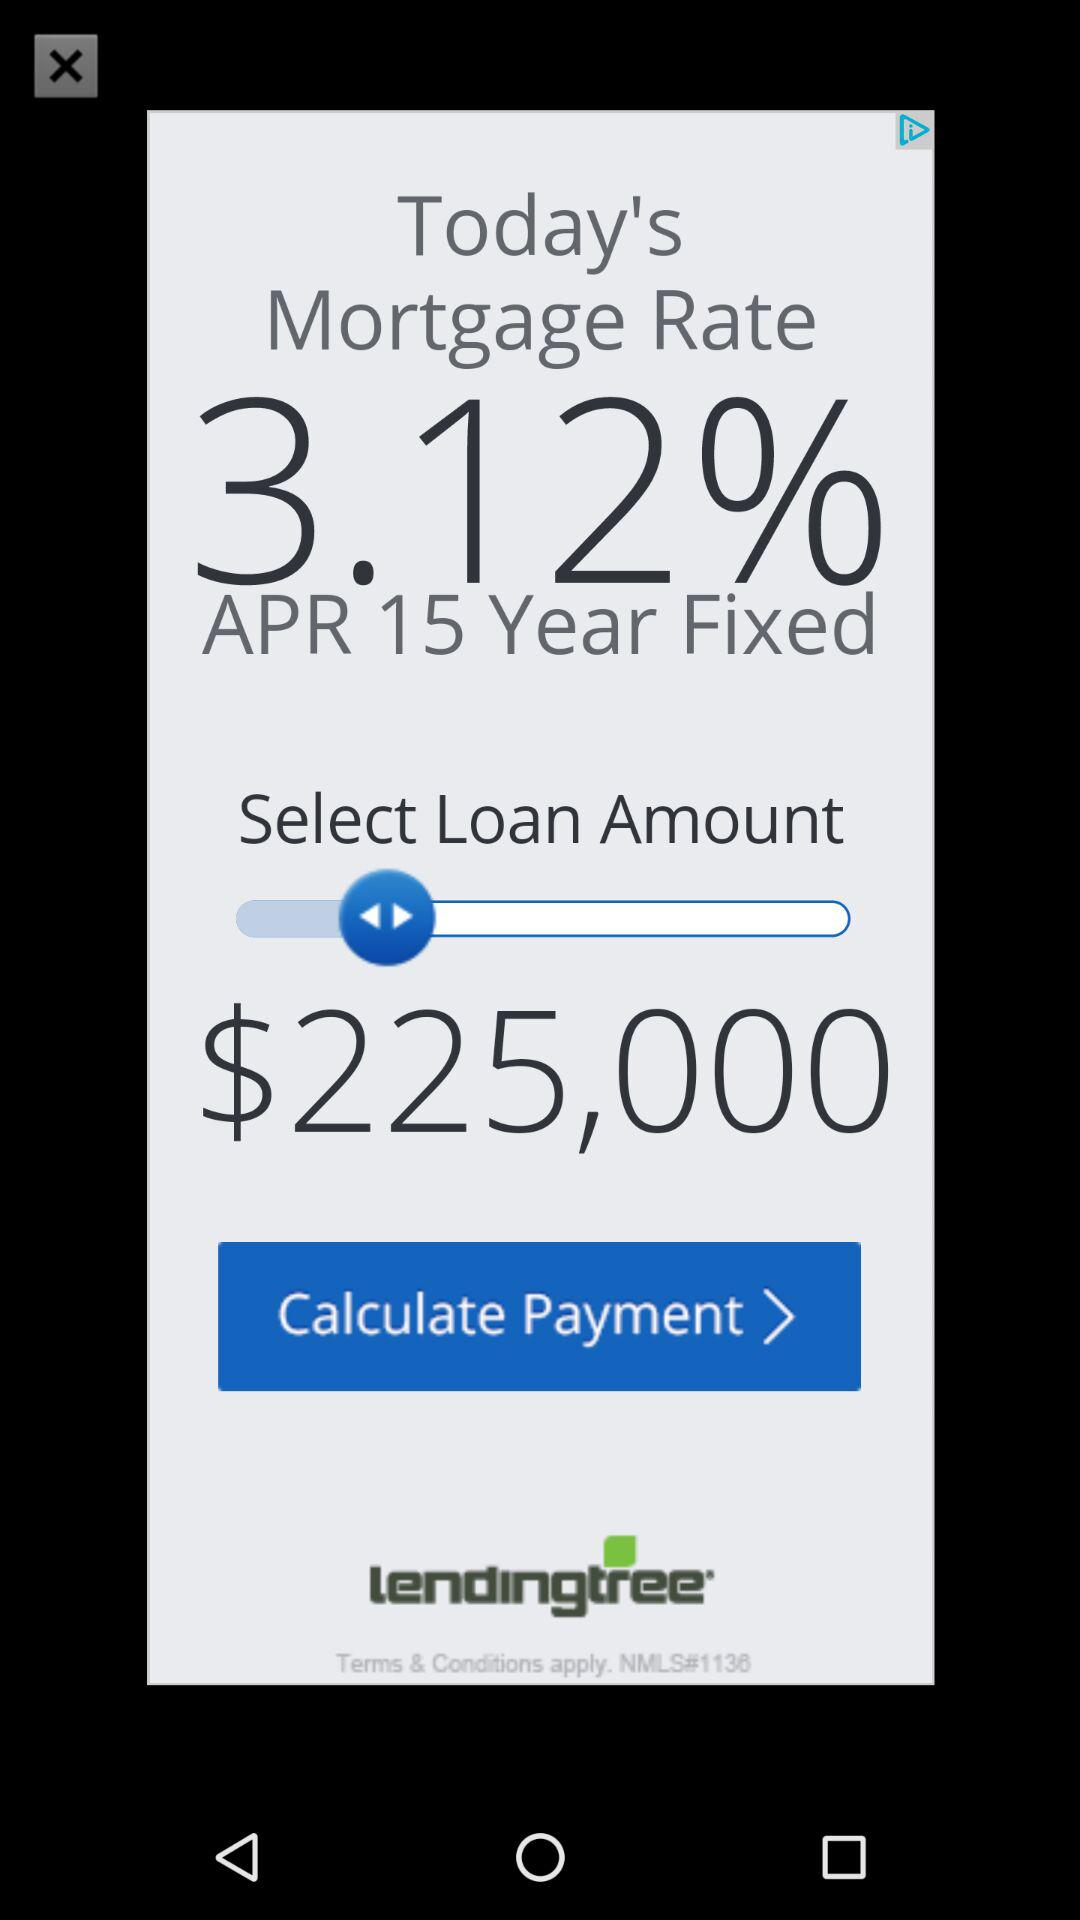For how many years is the mortgage fixed? The mortgage is fixed for 15 years. 